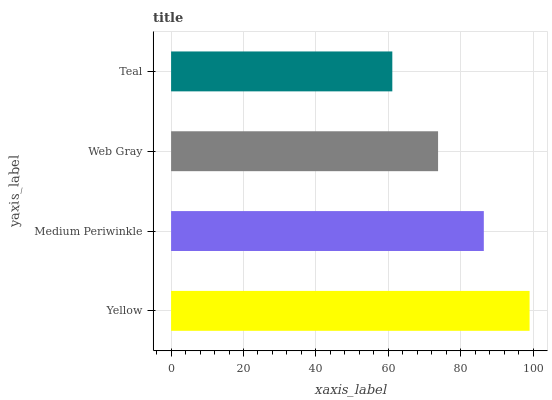Is Teal the minimum?
Answer yes or no. Yes. Is Yellow the maximum?
Answer yes or no. Yes. Is Medium Periwinkle the minimum?
Answer yes or no. No. Is Medium Periwinkle the maximum?
Answer yes or no. No. Is Yellow greater than Medium Periwinkle?
Answer yes or no. Yes. Is Medium Periwinkle less than Yellow?
Answer yes or no. Yes. Is Medium Periwinkle greater than Yellow?
Answer yes or no. No. Is Yellow less than Medium Periwinkle?
Answer yes or no. No. Is Medium Periwinkle the high median?
Answer yes or no. Yes. Is Web Gray the low median?
Answer yes or no. Yes. Is Web Gray the high median?
Answer yes or no. No. Is Teal the low median?
Answer yes or no. No. 